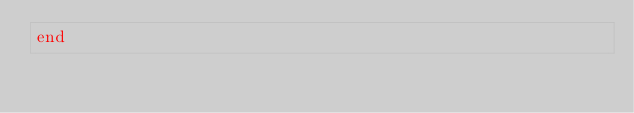Convert code to text. <code><loc_0><loc_0><loc_500><loc_500><_Ruby_>end
</code> 